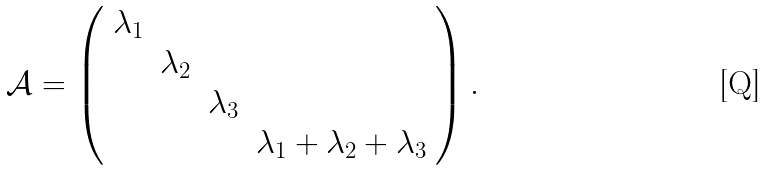<formula> <loc_0><loc_0><loc_500><loc_500>\mathcal { A } = \left ( \begin{array} { c c c c c c c c } \lambda _ { 1 } & & & \\ & \lambda _ { 2 } & & \\ & & \lambda _ { 3 } & \\ & & & \lambda _ { 1 } + \lambda _ { 2 } + \lambda _ { 3 } \\ \end{array} \right ) .</formula> 